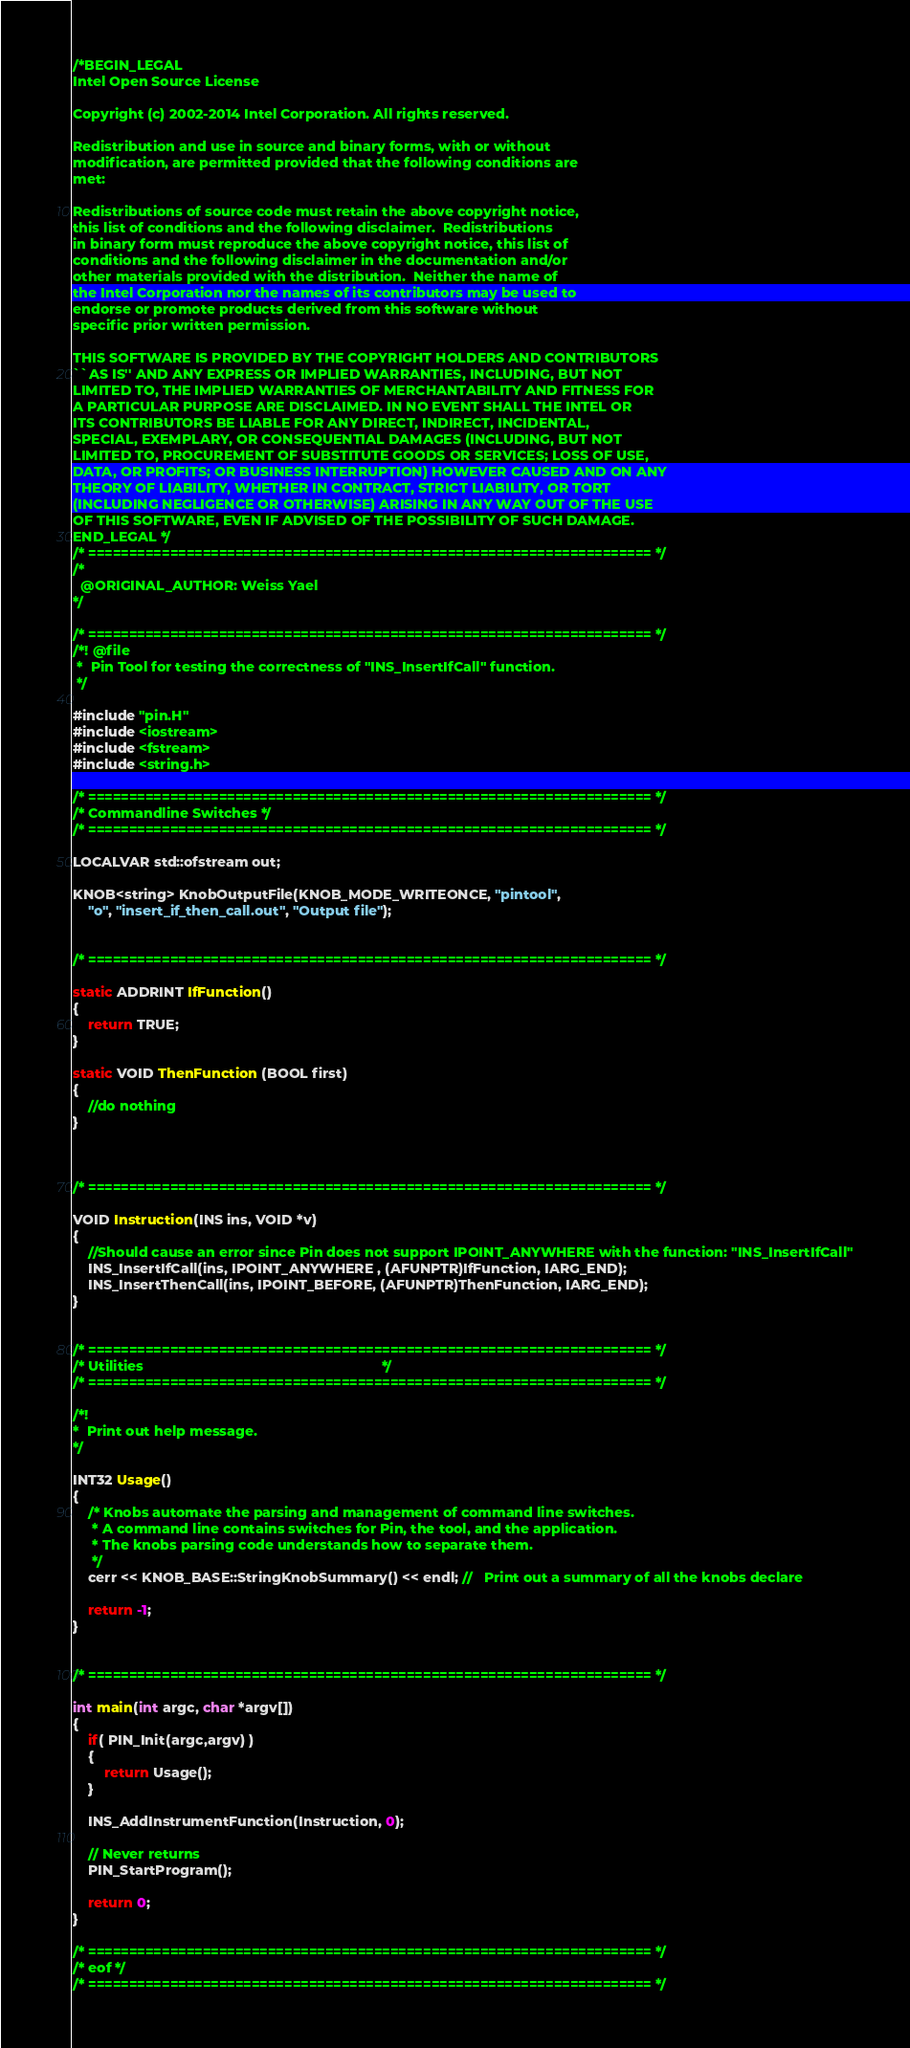Convert code to text. <code><loc_0><loc_0><loc_500><loc_500><_C++_>/*BEGIN_LEGAL 
Intel Open Source License 

Copyright (c) 2002-2014 Intel Corporation. All rights reserved.
 
Redistribution and use in source and binary forms, with or without
modification, are permitted provided that the following conditions are
met:

Redistributions of source code must retain the above copyright notice,
this list of conditions and the following disclaimer.  Redistributions
in binary form must reproduce the above copyright notice, this list of
conditions and the following disclaimer in the documentation and/or
other materials provided with the distribution.  Neither the name of
the Intel Corporation nor the names of its contributors may be used to
endorse or promote products derived from this software without
specific prior written permission.
 
THIS SOFTWARE IS PROVIDED BY THE COPYRIGHT HOLDERS AND CONTRIBUTORS
``AS IS'' AND ANY EXPRESS OR IMPLIED WARRANTIES, INCLUDING, BUT NOT
LIMITED TO, THE IMPLIED WARRANTIES OF MERCHANTABILITY AND FITNESS FOR
A PARTICULAR PURPOSE ARE DISCLAIMED. IN NO EVENT SHALL THE INTEL OR
ITS CONTRIBUTORS BE LIABLE FOR ANY DIRECT, INDIRECT, INCIDENTAL,
SPECIAL, EXEMPLARY, OR CONSEQUENTIAL DAMAGES (INCLUDING, BUT NOT
LIMITED TO, PROCUREMENT OF SUBSTITUTE GOODS OR SERVICES; LOSS OF USE,
DATA, OR PROFITS; OR BUSINESS INTERRUPTION) HOWEVER CAUSED AND ON ANY
THEORY OF LIABILITY, WHETHER IN CONTRACT, STRICT LIABILITY, OR TORT
(INCLUDING NEGLIGENCE OR OTHERWISE) ARISING IN ANY WAY OUT OF THE USE
OF THIS SOFTWARE, EVEN IF ADVISED OF THE POSSIBILITY OF SUCH DAMAGE.
END_LEGAL */
/* ===================================================================== */
/*
  @ORIGINAL_AUTHOR: Weiss Yael
*/

/* ===================================================================== */
/*! @file
 *  Pin Tool for testing the correctness of "INS_InsertIfCall" function.
 */

#include "pin.H"
#include <iostream>
#include <fstream>
#include <string.h>

/* ===================================================================== */
/* Commandline Switches */
/* ===================================================================== */

LOCALVAR std::ofstream out;

KNOB<string> KnobOutputFile(KNOB_MODE_WRITEONCE, "pintool",
    "o", "insert_if_then_call.out", "Output file");


/* ===================================================================== */

static ADDRINT IfFunction()
{
    return TRUE;
}

static VOID ThenFunction (BOOL first)
{
    //do nothing
}



/* ===================================================================== */

VOID Instruction(INS ins, VOID *v)
{
    //Should cause an error since Pin does not support IPOINT_ANYWHERE with the function: "INS_InsertIfCall"
    INS_InsertIfCall(ins, IPOINT_ANYWHERE , (AFUNPTR)IfFunction, IARG_END);
    INS_InsertThenCall(ins, IPOINT_BEFORE, (AFUNPTR)ThenFunction, IARG_END);
}


/* ===================================================================== */
/* Utilities                                                             */
/* ===================================================================== */

/*!
*  Print out help message.
*/

INT32 Usage()
{
	/* Knobs automate the parsing and management of command line switches. 
     * A command line contains switches for Pin, the tool, and the application. 
     * The knobs parsing code understands how to separate them. 
     */
    cerr << KNOB_BASE::StringKnobSummary() << endl; //   Print out a summary of all the knobs declare

    return -1;
}


/* ===================================================================== */

int main(int argc, char *argv[])
{
    if( PIN_Init(argc,argv) )
    {
        return Usage();
    }

    INS_AddInstrumentFunction(Instruction, 0);

    // Never returns
    PIN_StartProgram();
    
    return 0;
}

/* ===================================================================== */
/* eof */
/* ===================================================================== */
</code> 